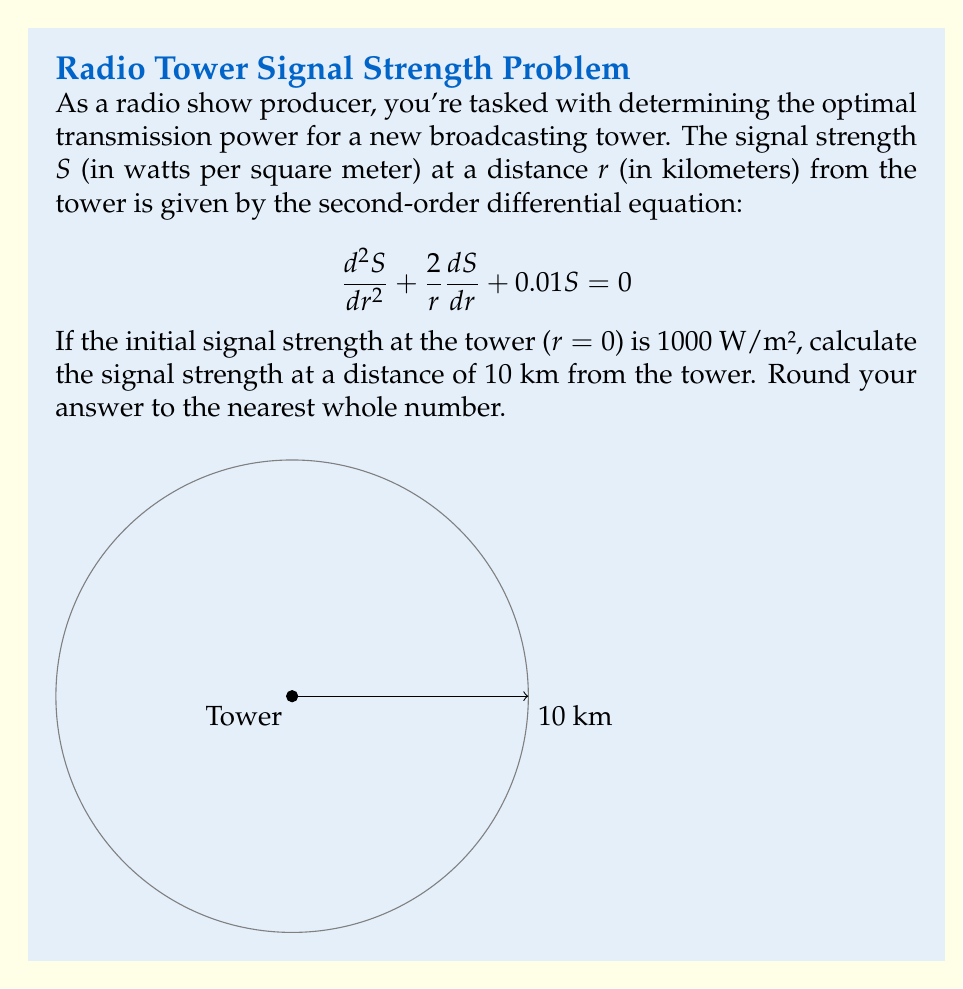Can you solve this math problem? To solve this problem, we need to follow these steps:

1) The given equation is a second-order linear differential equation. Its general solution is of the form:

   $$S(r) = \frac{A}{r}e^{-0.1r}$$

   where $A$ is a constant to be determined from the initial condition.

2) We're given that $S(0) = 1000$ W/m². However, we can't directly use $r=0$ in our solution as it would lead to division by zero. Instead, we need to use the limit as $r$ approaches 0:

   $$\lim_{r \to 0} S(r) = \lim_{r \to 0} \frac{A}{r}e^{-0.1r} = 1000$$

3) Using L'Hôpital's rule:

   $$\lim_{r \to 0} \frac{A}{r}e^{-0.1r} = \lim_{r \to 0} \frac{A(-0.1e^{-0.1r})}{1} = -0.1A = 1000$$

4) Solving for $A$:

   $$A = -10000$$

5) Now our specific solution is:

   $$S(r) = \frac{-10000}{r}e^{-0.1r}$$

6) To find the signal strength at 10 km, we substitute $r=10$:

   $$S(10) = \frac{-10000}{10}e^{-0.1(10)} = -1000e^{-1} \approx -367.88$$

7) Since signal strength is always positive, we take the absolute value:

   $$|S(10)| \approx 367.88$$

8) Rounding to the nearest whole number:

   $$S(10) \approx 368$$ W/m²
Answer: 368 W/m² 